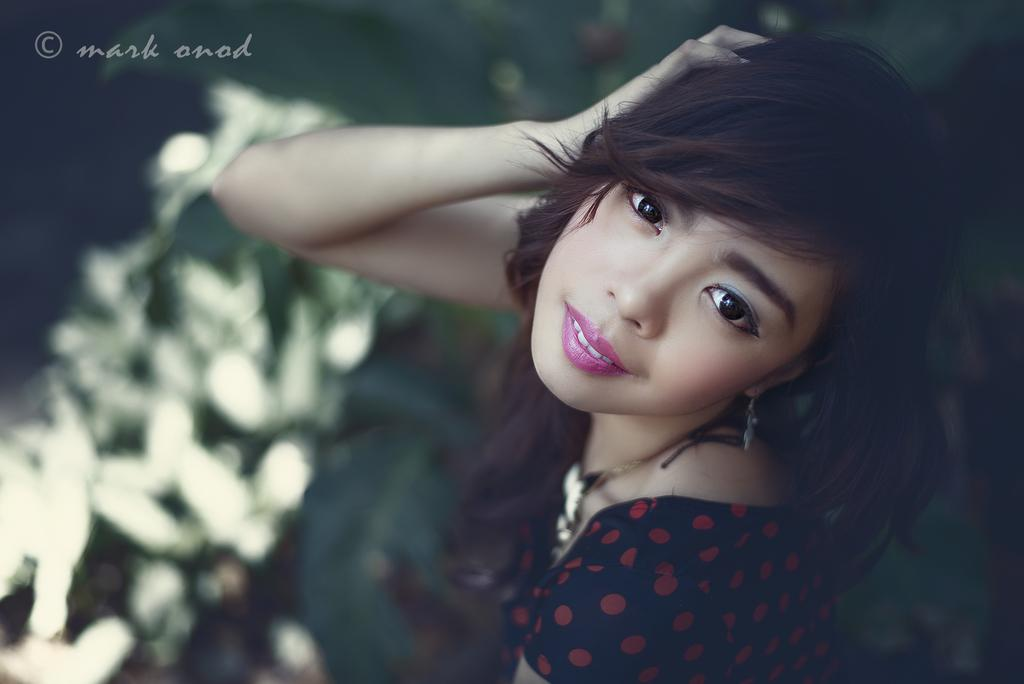What is the main subject of the image? There is a person in the image. What is the person wearing? The person is wearing a black and red color dress. Can you describe the background of the image? The background of the image is blurred. How many pies can be seen on the person's teeth in the image? There are no pies or teeth visible in the image, as it only features a person wearing a black and red dress with a blurred background. 